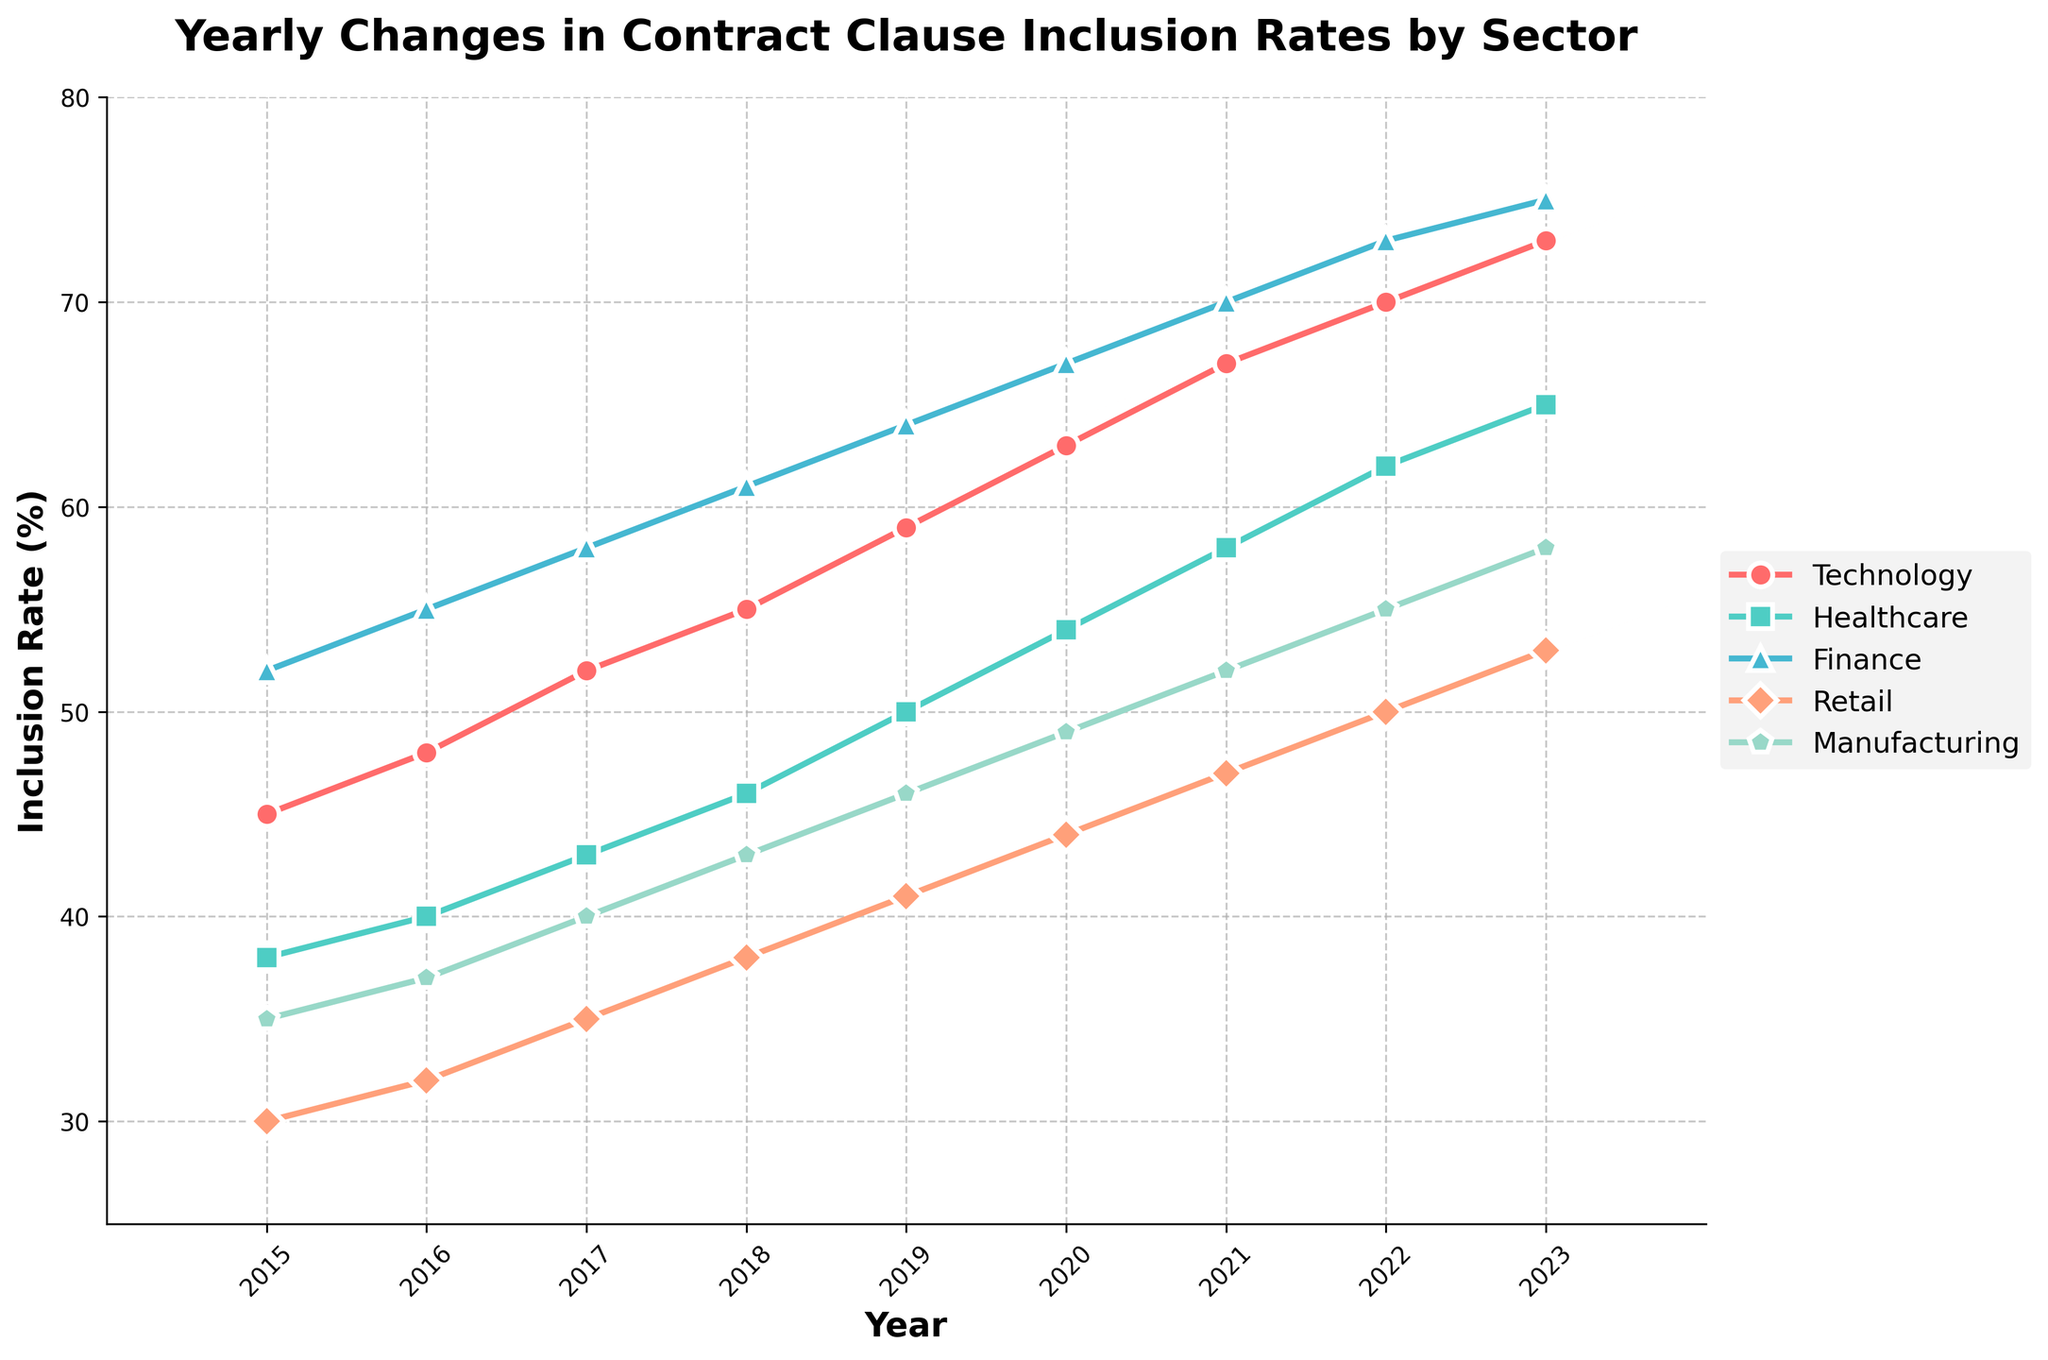Which sector had the highest inclusion rate in 2023? Scan the figure for the highest point in the year 2023. The sector with the highest point is the one with the highest inclusion rate.
Answer: Finance How did the inclusion rate of the Healthcare sector change from 2015 to 2023? Note the values for Healthcare in 2015 (38) and 2023 (65). Subtract the 2015 value from the 2023 value to determine the change. 65 - 38 = 27
Answer: Increased by 27 Which year did the Retail sector first reach an inclusion rate of 50% or more? Identify the first year in the Retail series where the inclusion rate is at least 50. This occurs in 2022 when the value is 50.
Answer: 2022 What is the average inclusion rate of the Technology sector from 2015 to 2023? Sum the yearly values for Technology (45 + 48 + 52 + 55 + 59 + 63 + 67 + 70 + 73) and divide by the number of years (9). (45 + 48 + 52 + 55 + 59 + 63 + 67 + 70 + 73) / 9 = 59.11
Answer: 59.11 Which sector showed the least increase in inclusion rate between 2015 and 2023? Calculate the increase for each sector by subtracting the 2015 value from the 2023 value: Technology (73 - 45), Healthcare (65 - 38), Finance (75 - 52), Retail (53 - 30), Manufacturing (58 - 35). Determine the smallest difference: Manufacturing with an increase of 23.
Answer: Manufacturing What is the difference in inclusion rate between Technology and Manufacturing in 2021? Identify the values for Technology (67) and Manufacturing (52) in 2021, then subtract the Manufacturing value from the Technology value. 67 - 52 = 15
Answer: 15 In which year did the Manufacturing sector have a 40% inclusion rate? Scan the values for Manufacturing and identify the year where the inclusion rate is exactly 40. This occurs in 2017.
Answer: 2017 Which sector saw a steady increase in inclusion rate every year from 2015 to 2023? Look for a sector where the inclusion rate increases each year without any decrease. Technology, Healthcare, Finance, Retail, and Manufacturing all fit this criterion.
Answer: All sectors (Technology, Healthcare, Finance, Retail, Manufacturing) Compare the inclusion rates of the Technology and Healthcare sectors in 2019. Which was higher and by how much? Identify the values for Technology (59) and Healthcare (50) in 2019. Subtract the Healthcare value from the Technology value to find the difference. 59 - 50 = 9, thus Technology is higher by 9.
Answer: Technology by 9 